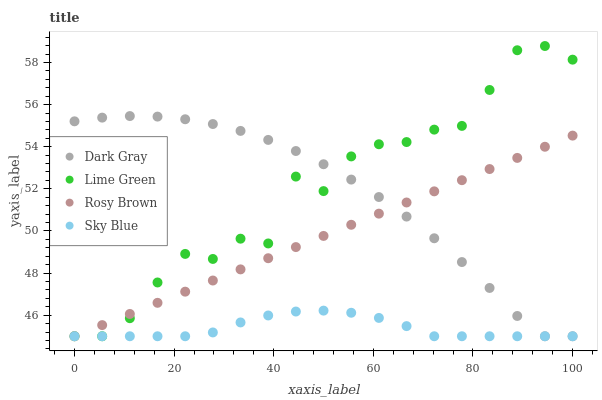Does Sky Blue have the minimum area under the curve?
Answer yes or no. Yes. Does Lime Green have the maximum area under the curve?
Answer yes or no. Yes. Does Rosy Brown have the minimum area under the curve?
Answer yes or no. No. Does Rosy Brown have the maximum area under the curve?
Answer yes or no. No. Is Rosy Brown the smoothest?
Answer yes or no. Yes. Is Lime Green the roughest?
Answer yes or no. Yes. Is Sky Blue the smoothest?
Answer yes or no. No. Is Sky Blue the roughest?
Answer yes or no. No. Does Dark Gray have the lowest value?
Answer yes or no. Yes. Does Lime Green have the highest value?
Answer yes or no. Yes. Does Rosy Brown have the highest value?
Answer yes or no. No. Does Lime Green intersect Rosy Brown?
Answer yes or no. Yes. Is Lime Green less than Rosy Brown?
Answer yes or no. No. Is Lime Green greater than Rosy Brown?
Answer yes or no. No. 